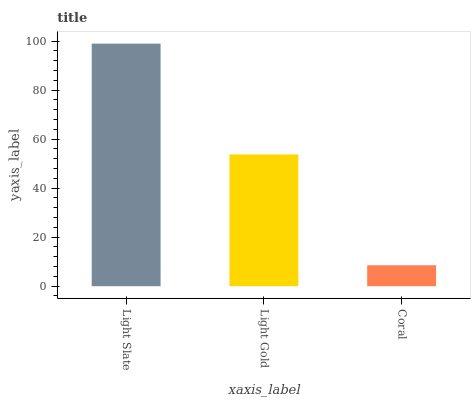Is Light Gold the minimum?
Answer yes or no. No. Is Light Gold the maximum?
Answer yes or no. No. Is Light Slate greater than Light Gold?
Answer yes or no. Yes. Is Light Gold less than Light Slate?
Answer yes or no. Yes. Is Light Gold greater than Light Slate?
Answer yes or no. No. Is Light Slate less than Light Gold?
Answer yes or no. No. Is Light Gold the high median?
Answer yes or no. Yes. Is Light Gold the low median?
Answer yes or no. Yes. Is Coral the high median?
Answer yes or no. No. Is Light Slate the low median?
Answer yes or no. No. 